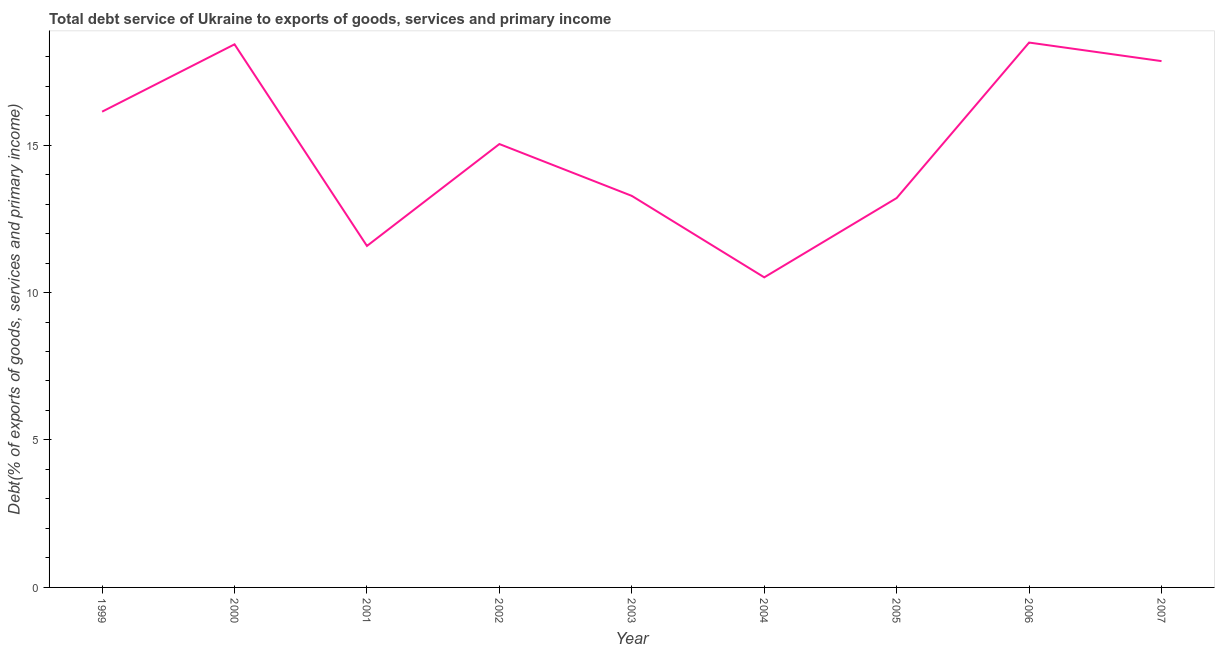What is the total debt service in 2005?
Your answer should be very brief. 13.2. Across all years, what is the maximum total debt service?
Give a very brief answer. 18.48. Across all years, what is the minimum total debt service?
Keep it short and to the point. 10.51. In which year was the total debt service maximum?
Your answer should be compact. 2006. What is the sum of the total debt service?
Keep it short and to the point. 134.48. What is the difference between the total debt service in 2002 and 2007?
Your answer should be very brief. -2.81. What is the average total debt service per year?
Your answer should be very brief. 14.94. What is the median total debt service?
Provide a short and direct response. 15.03. Do a majority of the years between 2000 and 2005 (inclusive) have total debt service greater than 14 %?
Your response must be concise. No. What is the ratio of the total debt service in 2000 to that in 2005?
Offer a very short reply. 1.39. Is the difference between the total debt service in 2005 and 2006 greater than the difference between any two years?
Make the answer very short. No. What is the difference between the highest and the second highest total debt service?
Your answer should be compact. 0.06. What is the difference between the highest and the lowest total debt service?
Give a very brief answer. 7.96. In how many years, is the total debt service greater than the average total debt service taken over all years?
Provide a short and direct response. 5. Does the total debt service monotonically increase over the years?
Offer a terse response. No. How many years are there in the graph?
Provide a succinct answer. 9. Does the graph contain any zero values?
Provide a short and direct response. No. Does the graph contain grids?
Your answer should be very brief. No. What is the title of the graph?
Give a very brief answer. Total debt service of Ukraine to exports of goods, services and primary income. What is the label or title of the X-axis?
Your answer should be compact. Year. What is the label or title of the Y-axis?
Your answer should be compact. Debt(% of exports of goods, services and primary income). What is the Debt(% of exports of goods, services and primary income) of 1999?
Your answer should be very brief. 16.13. What is the Debt(% of exports of goods, services and primary income) of 2000?
Give a very brief answer. 18.42. What is the Debt(% of exports of goods, services and primary income) in 2001?
Your answer should be very brief. 11.58. What is the Debt(% of exports of goods, services and primary income) of 2002?
Give a very brief answer. 15.03. What is the Debt(% of exports of goods, services and primary income) of 2003?
Keep it short and to the point. 13.28. What is the Debt(% of exports of goods, services and primary income) of 2004?
Ensure brevity in your answer.  10.51. What is the Debt(% of exports of goods, services and primary income) in 2005?
Your answer should be very brief. 13.2. What is the Debt(% of exports of goods, services and primary income) of 2006?
Ensure brevity in your answer.  18.48. What is the Debt(% of exports of goods, services and primary income) in 2007?
Keep it short and to the point. 17.85. What is the difference between the Debt(% of exports of goods, services and primary income) in 1999 and 2000?
Offer a terse response. -2.28. What is the difference between the Debt(% of exports of goods, services and primary income) in 1999 and 2001?
Offer a very short reply. 4.55. What is the difference between the Debt(% of exports of goods, services and primary income) in 1999 and 2002?
Give a very brief answer. 1.1. What is the difference between the Debt(% of exports of goods, services and primary income) in 1999 and 2003?
Your answer should be very brief. 2.86. What is the difference between the Debt(% of exports of goods, services and primary income) in 1999 and 2004?
Your answer should be compact. 5.62. What is the difference between the Debt(% of exports of goods, services and primary income) in 1999 and 2005?
Keep it short and to the point. 2.93. What is the difference between the Debt(% of exports of goods, services and primary income) in 1999 and 2006?
Make the answer very short. -2.34. What is the difference between the Debt(% of exports of goods, services and primary income) in 1999 and 2007?
Ensure brevity in your answer.  -1.71. What is the difference between the Debt(% of exports of goods, services and primary income) in 2000 and 2001?
Make the answer very short. 6.84. What is the difference between the Debt(% of exports of goods, services and primary income) in 2000 and 2002?
Provide a short and direct response. 3.38. What is the difference between the Debt(% of exports of goods, services and primary income) in 2000 and 2003?
Make the answer very short. 5.14. What is the difference between the Debt(% of exports of goods, services and primary income) in 2000 and 2004?
Ensure brevity in your answer.  7.9. What is the difference between the Debt(% of exports of goods, services and primary income) in 2000 and 2005?
Ensure brevity in your answer.  5.21. What is the difference between the Debt(% of exports of goods, services and primary income) in 2000 and 2006?
Offer a very short reply. -0.06. What is the difference between the Debt(% of exports of goods, services and primary income) in 2000 and 2007?
Offer a terse response. 0.57. What is the difference between the Debt(% of exports of goods, services and primary income) in 2001 and 2002?
Your response must be concise. -3.46. What is the difference between the Debt(% of exports of goods, services and primary income) in 2001 and 2003?
Give a very brief answer. -1.7. What is the difference between the Debt(% of exports of goods, services and primary income) in 2001 and 2004?
Your response must be concise. 1.06. What is the difference between the Debt(% of exports of goods, services and primary income) in 2001 and 2005?
Ensure brevity in your answer.  -1.62. What is the difference between the Debt(% of exports of goods, services and primary income) in 2001 and 2006?
Give a very brief answer. -6.9. What is the difference between the Debt(% of exports of goods, services and primary income) in 2001 and 2007?
Ensure brevity in your answer.  -6.27. What is the difference between the Debt(% of exports of goods, services and primary income) in 2002 and 2003?
Make the answer very short. 1.76. What is the difference between the Debt(% of exports of goods, services and primary income) in 2002 and 2004?
Offer a terse response. 4.52. What is the difference between the Debt(% of exports of goods, services and primary income) in 2002 and 2005?
Offer a very short reply. 1.83. What is the difference between the Debt(% of exports of goods, services and primary income) in 2002 and 2006?
Provide a succinct answer. -3.44. What is the difference between the Debt(% of exports of goods, services and primary income) in 2002 and 2007?
Offer a terse response. -2.81. What is the difference between the Debt(% of exports of goods, services and primary income) in 2003 and 2004?
Offer a very short reply. 2.76. What is the difference between the Debt(% of exports of goods, services and primary income) in 2003 and 2005?
Provide a succinct answer. 0.07. What is the difference between the Debt(% of exports of goods, services and primary income) in 2003 and 2006?
Keep it short and to the point. -5.2. What is the difference between the Debt(% of exports of goods, services and primary income) in 2003 and 2007?
Provide a short and direct response. -4.57. What is the difference between the Debt(% of exports of goods, services and primary income) in 2004 and 2005?
Give a very brief answer. -2.69. What is the difference between the Debt(% of exports of goods, services and primary income) in 2004 and 2006?
Your answer should be compact. -7.96. What is the difference between the Debt(% of exports of goods, services and primary income) in 2004 and 2007?
Provide a succinct answer. -7.33. What is the difference between the Debt(% of exports of goods, services and primary income) in 2005 and 2006?
Make the answer very short. -5.27. What is the difference between the Debt(% of exports of goods, services and primary income) in 2005 and 2007?
Make the answer very short. -4.64. What is the difference between the Debt(% of exports of goods, services and primary income) in 2006 and 2007?
Make the answer very short. 0.63. What is the ratio of the Debt(% of exports of goods, services and primary income) in 1999 to that in 2000?
Ensure brevity in your answer.  0.88. What is the ratio of the Debt(% of exports of goods, services and primary income) in 1999 to that in 2001?
Provide a succinct answer. 1.39. What is the ratio of the Debt(% of exports of goods, services and primary income) in 1999 to that in 2002?
Your answer should be very brief. 1.07. What is the ratio of the Debt(% of exports of goods, services and primary income) in 1999 to that in 2003?
Offer a very short reply. 1.22. What is the ratio of the Debt(% of exports of goods, services and primary income) in 1999 to that in 2004?
Provide a short and direct response. 1.53. What is the ratio of the Debt(% of exports of goods, services and primary income) in 1999 to that in 2005?
Offer a very short reply. 1.22. What is the ratio of the Debt(% of exports of goods, services and primary income) in 1999 to that in 2006?
Make the answer very short. 0.87. What is the ratio of the Debt(% of exports of goods, services and primary income) in 1999 to that in 2007?
Ensure brevity in your answer.  0.9. What is the ratio of the Debt(% of exports of goods, services and primary income) in 2000 to that in 2001?
Your response must be concise. 1.59. What is the ratio of the Debt(% of exports of goods, services and primary income) in 2000 to that in 2002?
Keep it short and to the point. 1.23. What is the ratio of the Debt(% of exports of goods, services and primary income) in 2000 to that in 2003?
Keep it short and to the point. 1.39. What is the ratio of the Debt(% of exports of goods, services and primary income) in 2000 to that in 2004?
Make the answer very short. 1.75. What is the ratio of the Debt(% of exports of goods, services and primary income) in 2000 to that in 2005?
Provide a short and direct response. 1.4. What is the ratio of the Debt(% of exports of goods, services and primary income) in 2000 to that in 2007?
Offer a very short reply. 1.03. What is the ratio of the Debt(% of exports of goods, services and primary income) in 2001 to that in 2002?
Offer a terse response. 0.77. What is the ratio of the Debt(% of exports of goods, services and primary income) in 2001 to that in 2003?
Your response must be concise. 0.87. What is the ratio of the Debt(% of exports of goods, services and primary income) in 2001 to that in 2004?
Keep it short and to the point. 1.1. What is the ratio of the Debt(% of exports of goods, services and primary income) in 2001 to that in 2005?
Keep it short and to the point. 0.88. What is the ratio of the Debt(% of exports of goods, services and primary income) in 2001 to that in 2006?
Your answer should be very brief. 0.63. What is the ratio of the Debt(% of exports of goods, services and primary income) in 2001 to that in 2007?
Keep it short and to the point. 0.65. What is the ratio of the Debt(% of exports of goods, services and primary income) in 2002 to that in 2003?
Provide a succinct answer. 1.13. What is the ratio of the Debt(% of exports of goods, services and primary income) in 2002 to that in 2004?
Make the answer very short. 1.43. What is the ratio of the Debt(% of exports of goods, services and primary income) in 2002 to that in 2005?
Your response must be concise. 1.14. What is the ratio of the Debt(% of exports of goods, services and primary income) in 2002 to that in 2006?
Your response must be concise. 0.81. What is the ratio of the Debt(% of exports of goods, services and primary income) in 2002 to that in 2007?
Provide a short and direct response. 0.84. What is the ratio of the Debt(% of exports of goods, services and primary income) in 2003 to that in 2004?
Your answer should be compact. 1.26. What is the ratio of the Debt(% of exports of goods, services and primary income) in 2003 to that in 2006?
Offer a terse response. 0.72. What is the ratio of the Debt(% of exports of goods, services and primary income) in 2003 to that in 2007?
Your answer should be compact. 0.74. What is the ratio of the Debt(% of exports of goods, services and primary income) in 2004 to that in 2005?
Make the answer very short. 0.8. What is the ratio of the Debt(% of exports of goods, services and primary income) in 2004 to that in 2006?
Provide a succinct answer. 0.57. What is the ratio of the Debt(% of exports of goods, services and primary income) in 2004 to that in 2007?
Make the answer very short. 0.59. What is the ratio of the Debt(% of exports of goods, services and primary income) in 2005 to that in 2006?
Provide a short and direct response. 0.71. What is the ratio of the Debt(% of exports of goods, services and primary income) in 2005 to that in 2007?
Make the answer very short. 0.74. What is the ratio of the Debt(% of exports of goods, services and primary income) in 2006 to that in 2007?
Provide a short and direct response. 1.03. 